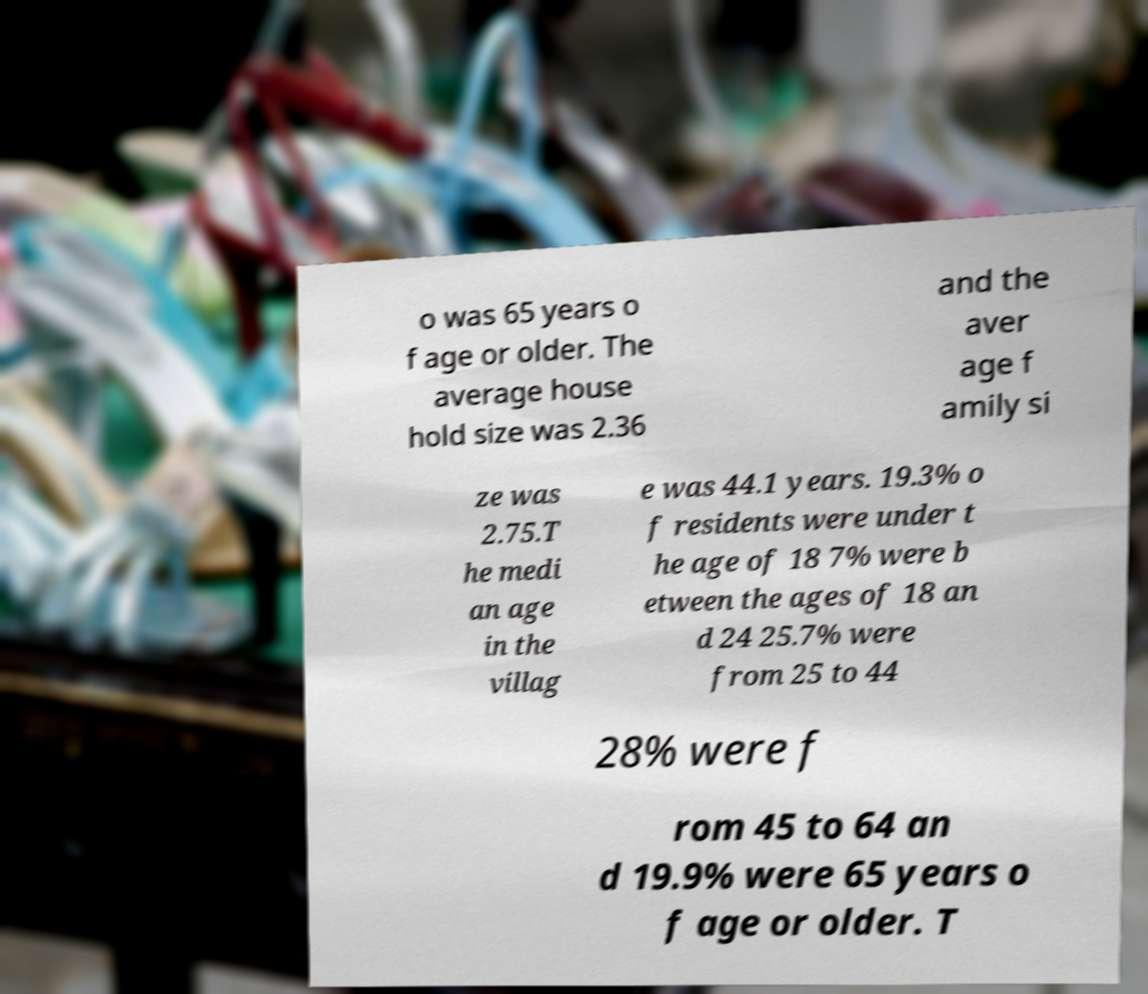Could you assist in decoding the text presented in this image and type it out clearly? o was 65 years o f age or older. The average house hold size was 2.36 and the aver age f amily si ze was 2.75.T he medi an age in the villag e was 44.1 years. 19.3% o f residents were under t he age of 18 7% were b etween the ages of 18 an d 24 25.7% were from 25 to 44 28% were f rom 45 to 64 an d 19.9% were 65 years o f age or older. T 